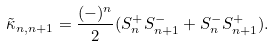Convert formula to latex. <formula><loc_0><loc_0><loc_500><loc_500>\tilde { \kappa } _ { n , n + 1 } = \frac { ( - ) ^ { n } } { 2 } ( S ^ { + } _ { n } { S } ^ { - } _ { n + 1 } + S ^ { - } _ { n } { S } ^ { + } _ { n + 1 } ) .</formula> 